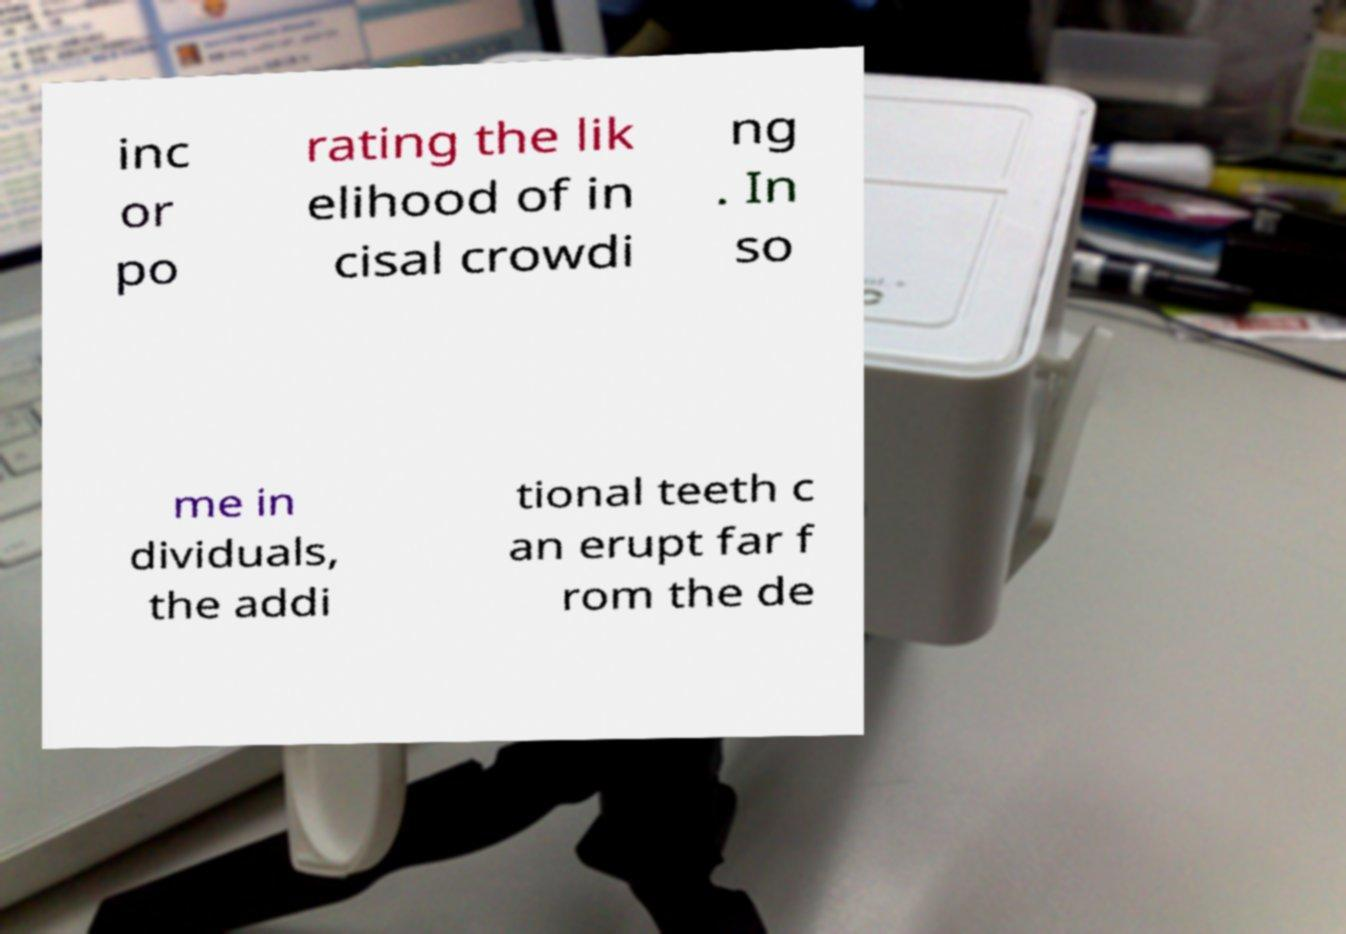Could you extract and type out the text from this image? inc or po rating the lik elihood of in cisal crowdi ng . In so me in dividuals, the addi tional teeth c an erupt far f rom the de 